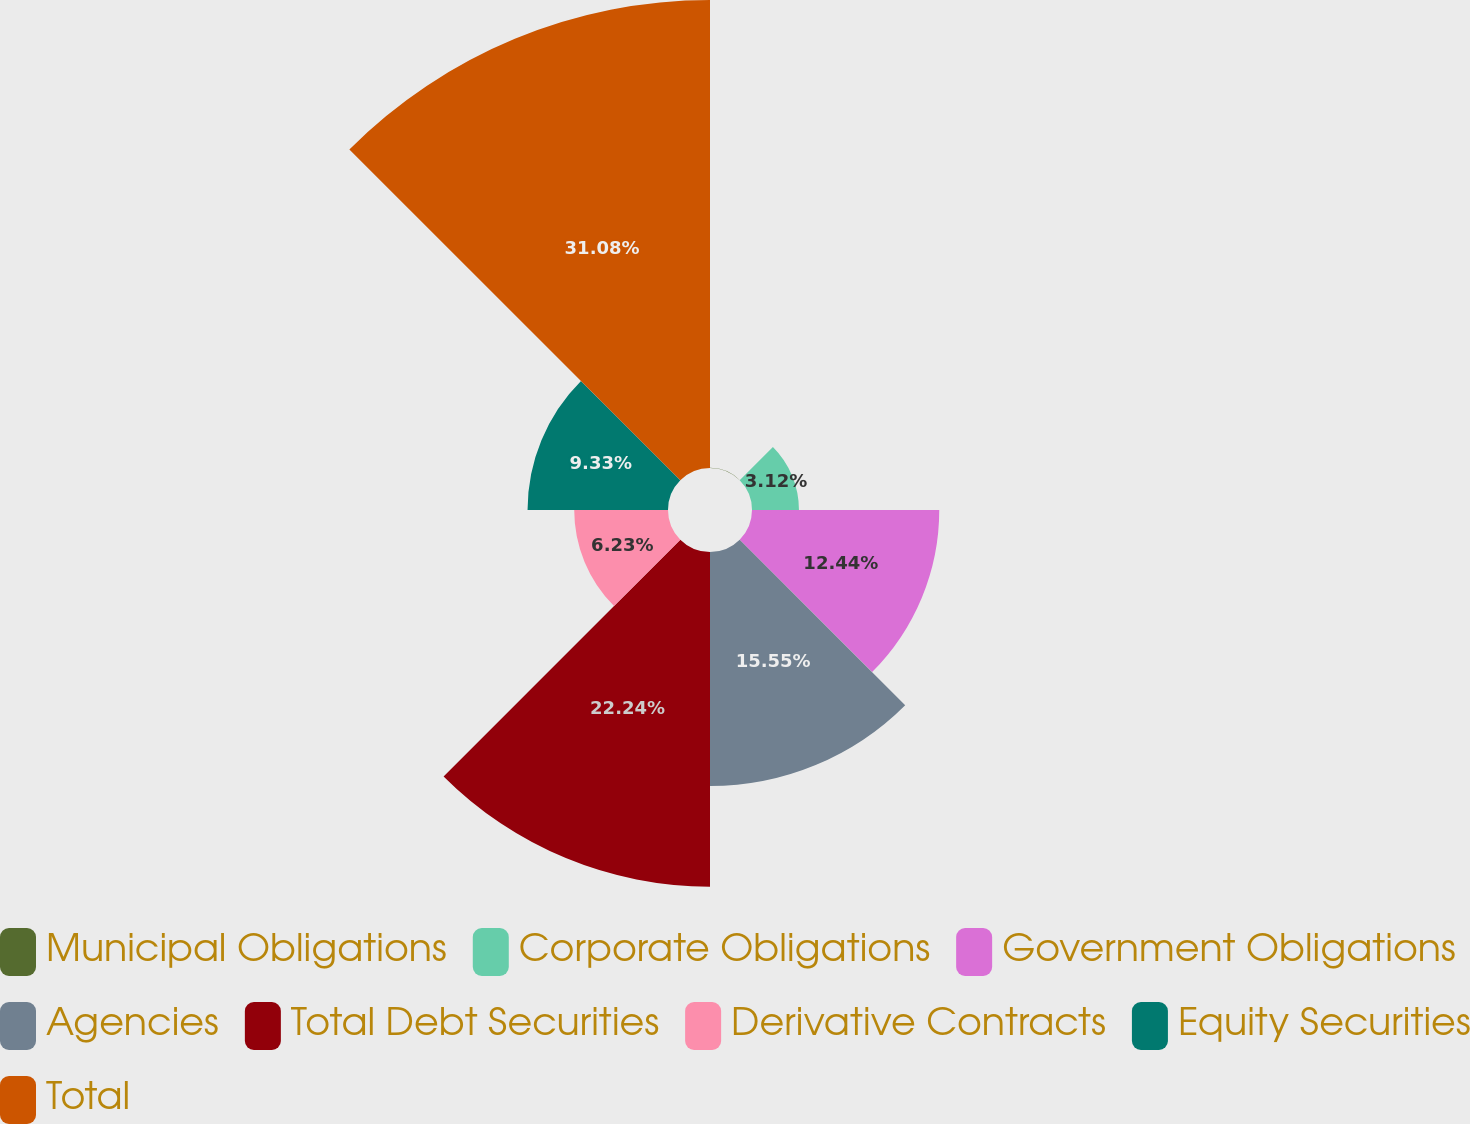<chart> <loc_0><loc_0><loc_500><loc_500><pie_chart><fcel>Municipal Obligations<fcel>Corporate Obligations<fcel>Government Obligations<fcel>Agencies<fcel>Total Debt Securities<fcel>Derivative Contracts<fcel>Equity Securities<fcel>Total<nl><fcel>0.01%<fcel>3.12%<fcel>12.44%<fcel>15.55%<fcel>22.24%<fcel>6.23%<fcel>9.33%<fcel>31.09%<nl></chart> 